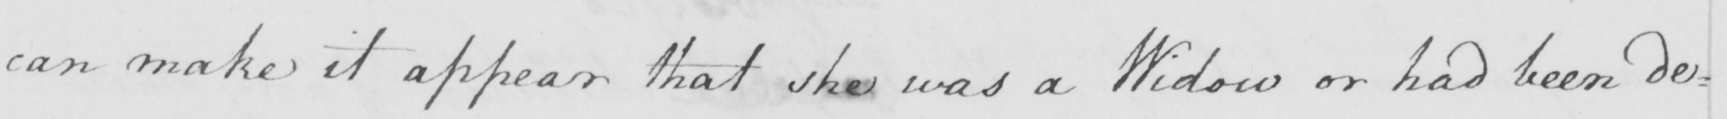Can you tell me what this handwritten text says? can make it appear that she was a Widow or had been de= 